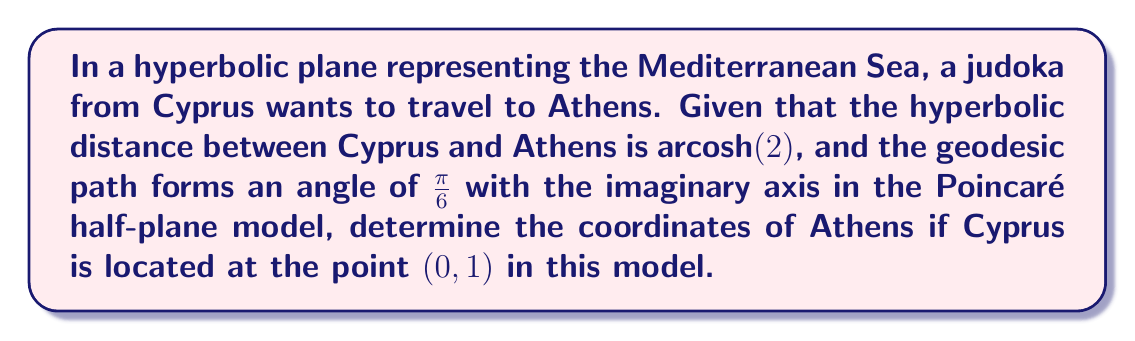Teach me how to tackle this problem. Let's approach this step-by-step:

1) In the Poincaré half-plane model, geodesics are either vertical lines or semicircles centered on the real axis.

2) Given that the path forms an angle of $\frac{\pi}{6}$ with the imaginary axis, it's not a vertical line. Therefore, it's a semicircle.

3) The general equation of a semicircle in the Poincaré half-plane model is:

   $$(x-a)^2 + y^2 = r^2$$

   where $(a,0)$ is the center on the real axis and $r$ is the radius.

4) For a semicircle passing through $(0,1)$ at an angle of $\frac{\pi}{6}$ with the imaginary axis:

   $a = \cot(\frac{\pi}{6}) = \sqrt{3}$
   $r = \sqrt{1 + (\sqrt{3})^2} = 2$

5) So, the equation of our geodesic is:

   $$(x-\sqrt{3})^2 + y^2 = 4$$

6) The hyperbolic distance along this geodesic is given by:

   $$d = \text{arcosh}(\frac{1+|z_1-z_2|^2}{2y_1y_2})$$

   where $z_1 = 0+i$ and $z_2 = x+yi$ are the complex representations of the two points.

7) We're given that $d = \text{arcosh}(2)$, so:

   $$2 = \frac{1+|x+yi-i|^2}{2y}$$

8) Simplifying:

   $$4y = 1+x^2+(y-1)^2 = x^2+y^2-2y+2$$

9) Combining this with the equation of the semicircle:

   $$x^2+y^2-2y+2 = 4y$$
   $$x^2+y^2-6y+2 = 0$$
   $$(x-\sqrt{3})^2 + y^2 = 4$$

10) Solving these simultaneously:

    $x = \sqrt{3}$
    $y = 1$

Therefore, the coordinates of Athens in this model are $(\sqrt{3}, 1)$.
Answer: $(\sqrt{3}, 1)$ 